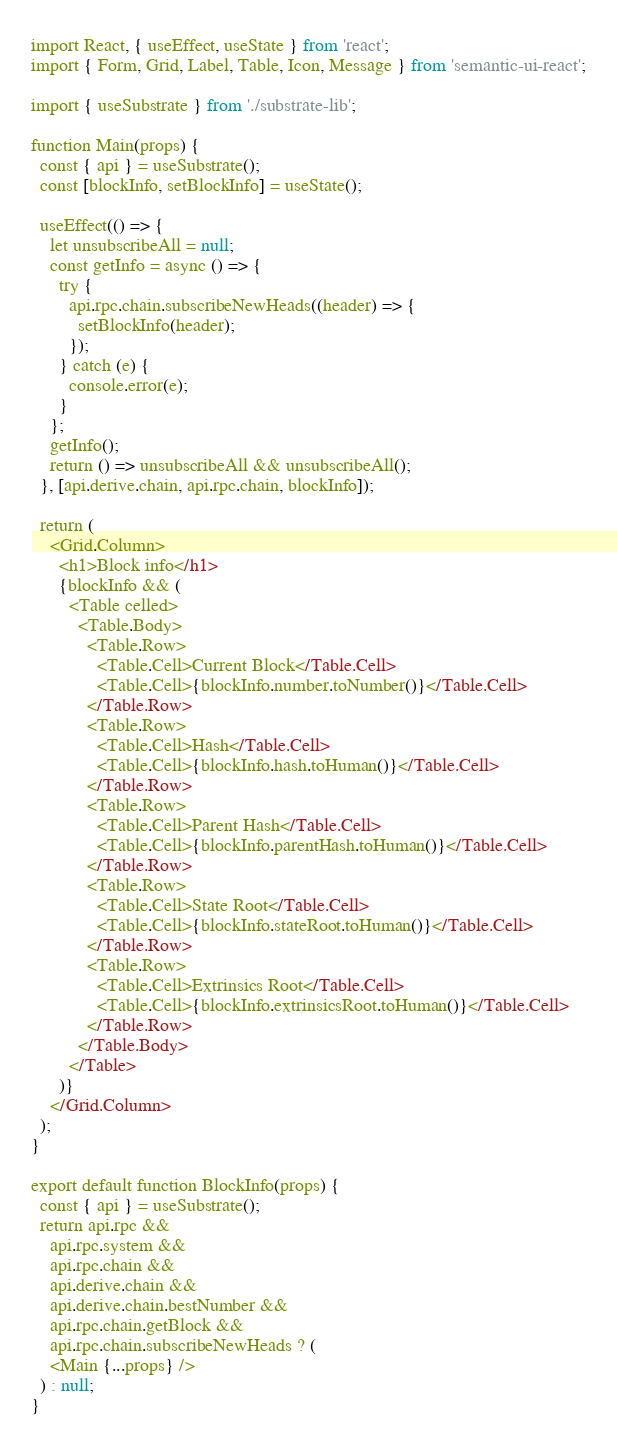Convert code to text. <code><loc_0><loc_0><loc_500><loc_500><_JavaScript_>import React, { useEffect, useState } from 'react';
import { Form, Grid, Label, Table, Icon, Message } from 'semantic-ui-react';

import { useSubstrate } from './substrate-lib';

function Main(props) {
  const { api } = useSubstrate();
  const [blockInfo, setBlockInfo] = useState();

  useEffect(() => {
    let unsubscribeAll = null;
    const getInfo = async () => {
      try {
        api.rpc.chain.subscribeNewHeads((header) => {
          setBlockInfo(header);
        });
      } catch (e) {
        console.error(e);
      }
    };
    getInfo();
    return () => unsubscribeAll && unsubscribeAll();
  }, [api.derive.chain, api.rpc.chain, blockInfo]);

  return (
    <Grid.Column>
      <h1>Block info</h1>
      {blockInfo && (
        <Table celled>
          <Table.Body>
            <Table.Row>
              <Table.Cell>Current Block</Table.Cell>
              <Table.Cell>{blockInfo.number.toNumber()}</Table.Cell>
            </Table.Row>
            <Table.Row>
              <Table.Cell>Hash</Table.Cell>
              <Table.Cell>{blockInfo.hash.toHuman()}</Table.Cell>
            </Table.Row>
            <Table.Row>
              <Table.Cell>Parent Hash</Table.Cell>
              <Table.Cell>{blockInfo.parentHash.toHuman()}</Table.Cell>
            </Table.Row>
            <Table.Row>
              <Table.Cell>State Root</Table.Cell>
              <Table.Cell>{blockInfo.stateRoot.toHuman()}</Table.Cell>
            </Table.Row>
            <Table.Row>
              <Table.Cell>Extrinsics Root</Table.Cell>
              <Table.Cell>{blockInfo.extrinsicsRoot.toHuman()}</Table.Cell>
            </Table.Row>
          </Table.Body>
        </Table>
      )}
    </Grid.Column>
  );
}

export default function BlockInfo(props) {
  const { api } = useSubstrate();
  return api.rpc &&
    api.rpc.system &&
    api.rpc.chain &&
    api.derive.chain &&
    api.derive.chain.bestNumber &&
    api.rpc.chain.getBlock &&
    api.rpc.chain.subscribeNewHeads ? (
    <Main {...props} />
  ) : null;
}</code> 